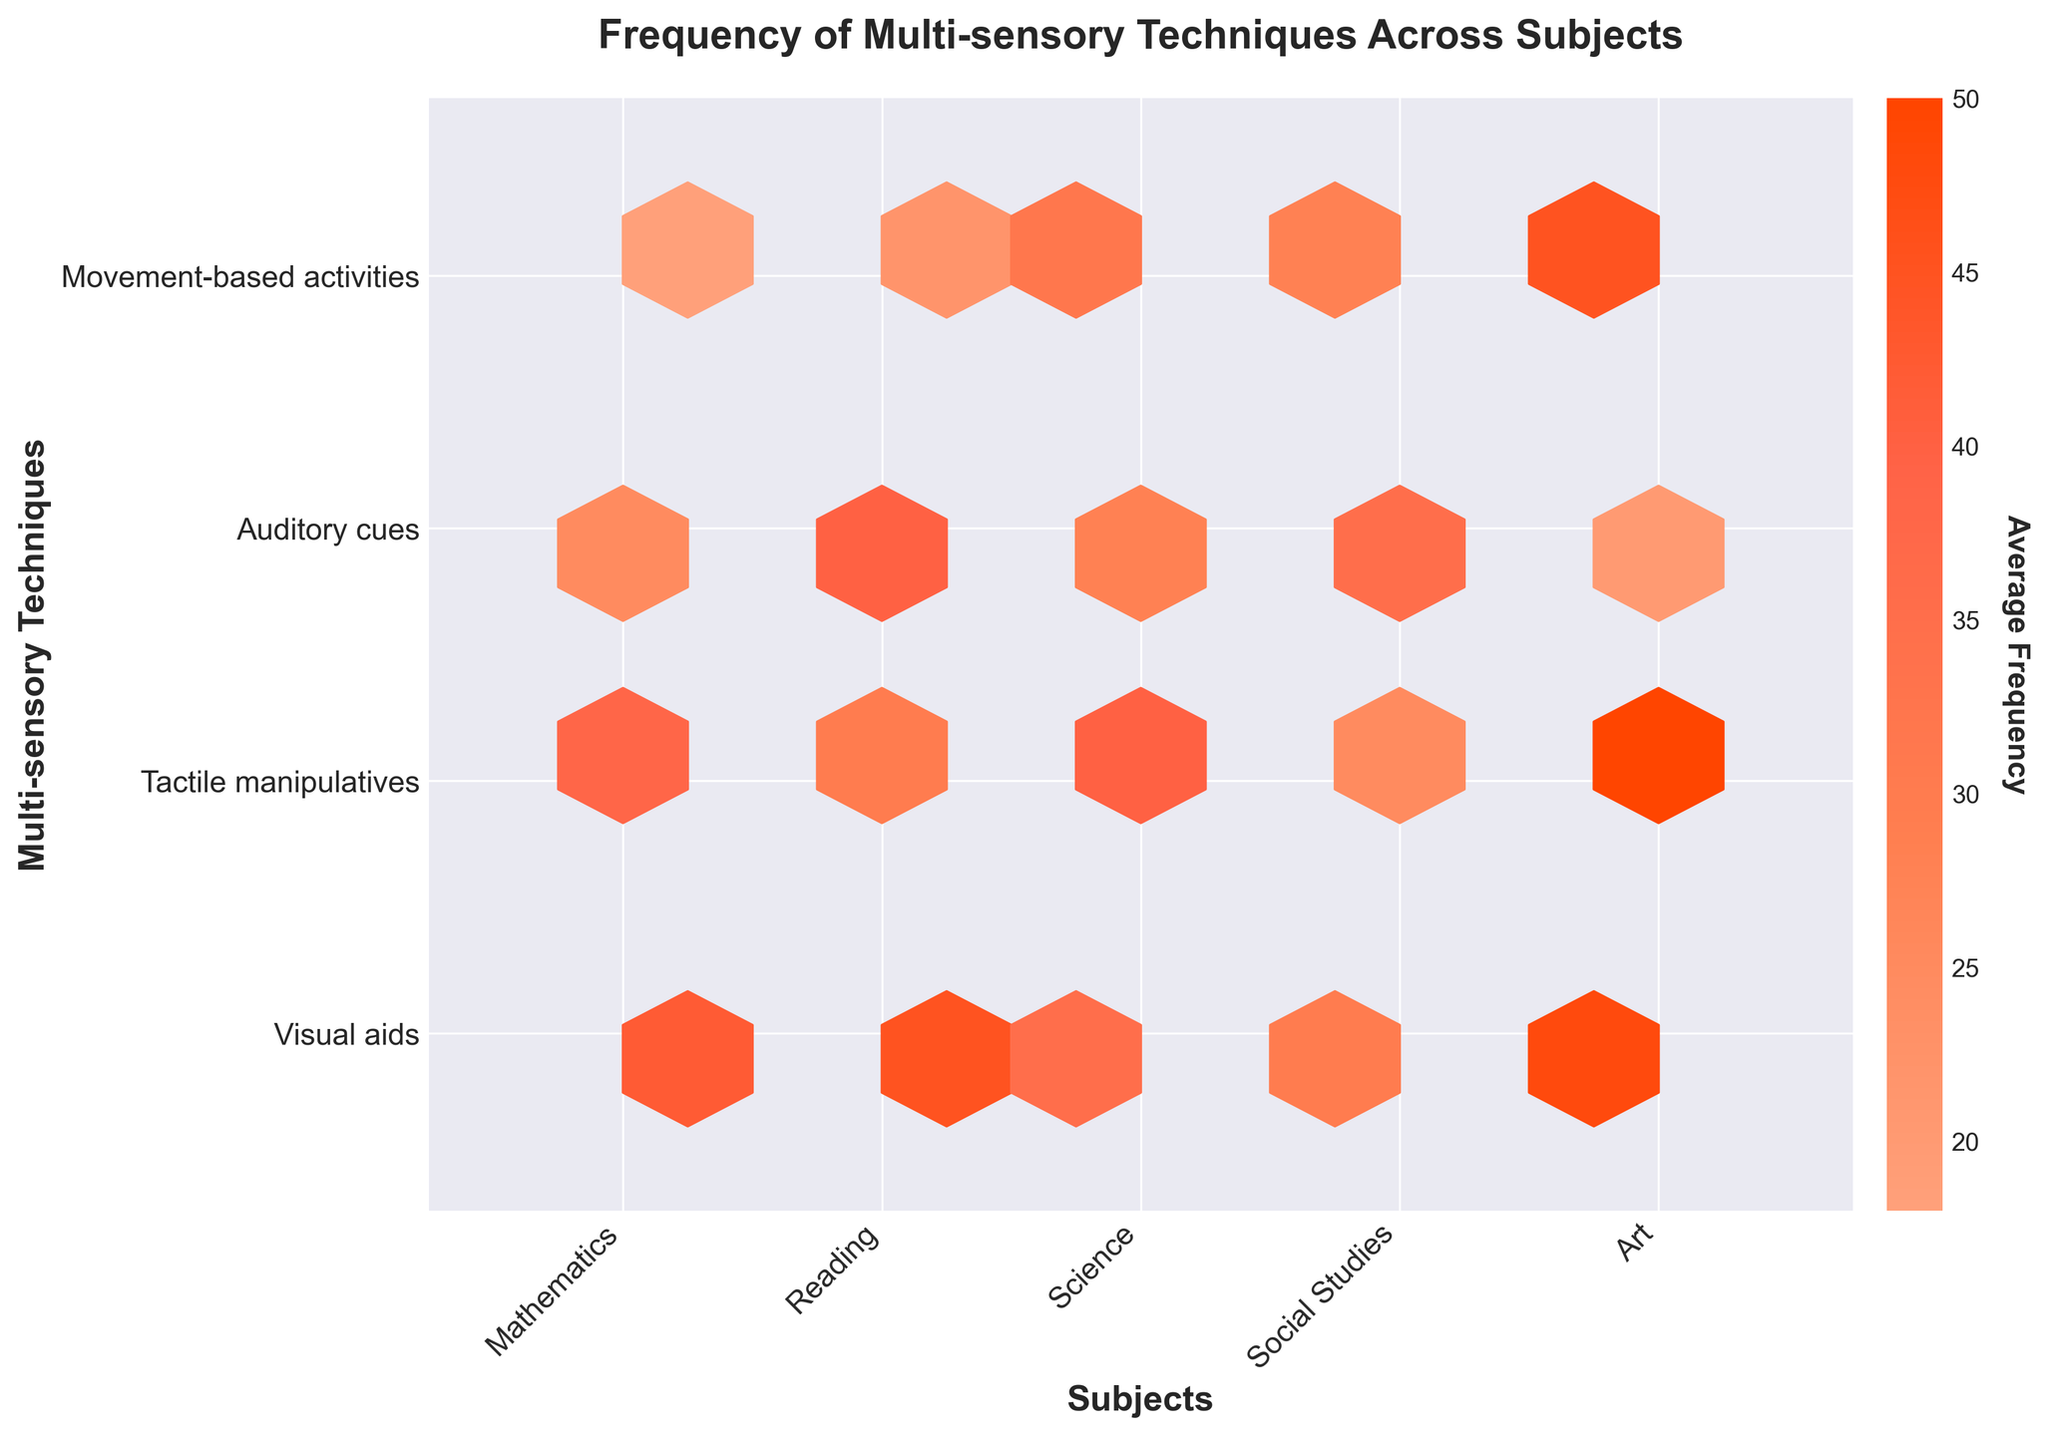What's the title of the chart? The title is typically located at the top of the chart in bold text. In this figure, it reads: "Frequency of Multi-sensory Techniques Across Subjects."
Answer: Frequency of Multi-sensory Techniques Across Subjects What is the x-axis labeled? The label on the x-axis can be found below the axis line. In this figure, the x-axis is labeled as "Subjects."
Answer: Subjects Which subject has the highest frequency of Visual aids? To find this, locate the y-axis label "Visual aids" and move horizontally to find the subject with the brightest hexbin indicating the highest frequency. In this case, "Art" has the highest frequency value.
Answer: Art Which multi-sensory technique is most frequently used in Science? Locate the column for "Science" on the x-axis, then check vertically which technique (y-axis) corresponds to the brightest hexbin. "Tactile manipulatives" show the highest value.
Answer: Tactile manipulatives Compare the frequencies of Movement-based activities between Mathematics and Art. Which subject has the higher frequency? Locate "Movement-based activities" along the y-axis and compare the intensity of the hexbin for "Mathematics" and "Art" on the x-axis. "Art" has the higher frequency as indicated by a brighter hexbin.
Answer: Art What is the average frequency of Tactile manipulatives across all subjects? To determine the average, sum up the frequencies for "Tactile manipulatives" across all subjects and divide by the number of subjects:
Mathematics (38) + Reading (30) + Science (40) + Social Studies (25) + Art (50) = 183. Divide by number of subjects (5): 183/5 = 36.6
Answer: 36.6 Which multi-sensory technique has the lowest average frequency across all subjects? Calculate the average for each technique by summing their frequencies in each subject and dividing by the number of subjects, then compare these averages:
- Visual aids: (42 + 45 + 35 + 30 + 48) / 5 = 40
- Tactile manipulatives: (38 + 30 + 40 + 25 + 50) / 5 = 36.6
- Auditory cues: (25 + 40 + 28 + 35 + 20) / 5 = 29.6
- Movement-based activities: (18 + 22 + 32 + 28 + 45) / 5 = 29
Auditory cues have the lowest average frequency.
Answer: Auditory cues In which subject is the use of Auditory cues the most and least frequent? Locate "Auditory cues" along the y-axis and check the corresponding hexbin brightness for each subject (x-axis). Reading shows the brightest hexbin indicating the highest frequency (40), while Art has the least frequency (20).
Answer: Most: Reading, Least: Art How does the frequency of use for Visual aids in Social Studies compare to Tactile manipulatives in the same subject? Locate "Social Studies" on the x-axis and compare the hexbin brightness at the intersection with "Visual aids" and "Tactile manipulatives" on the y-axis. The hexbin for Visual aids is brighter, indicating a higher frequency (30) compared to Tactile manipulatives (25).
Answer: Visual aids have a higher frequency 